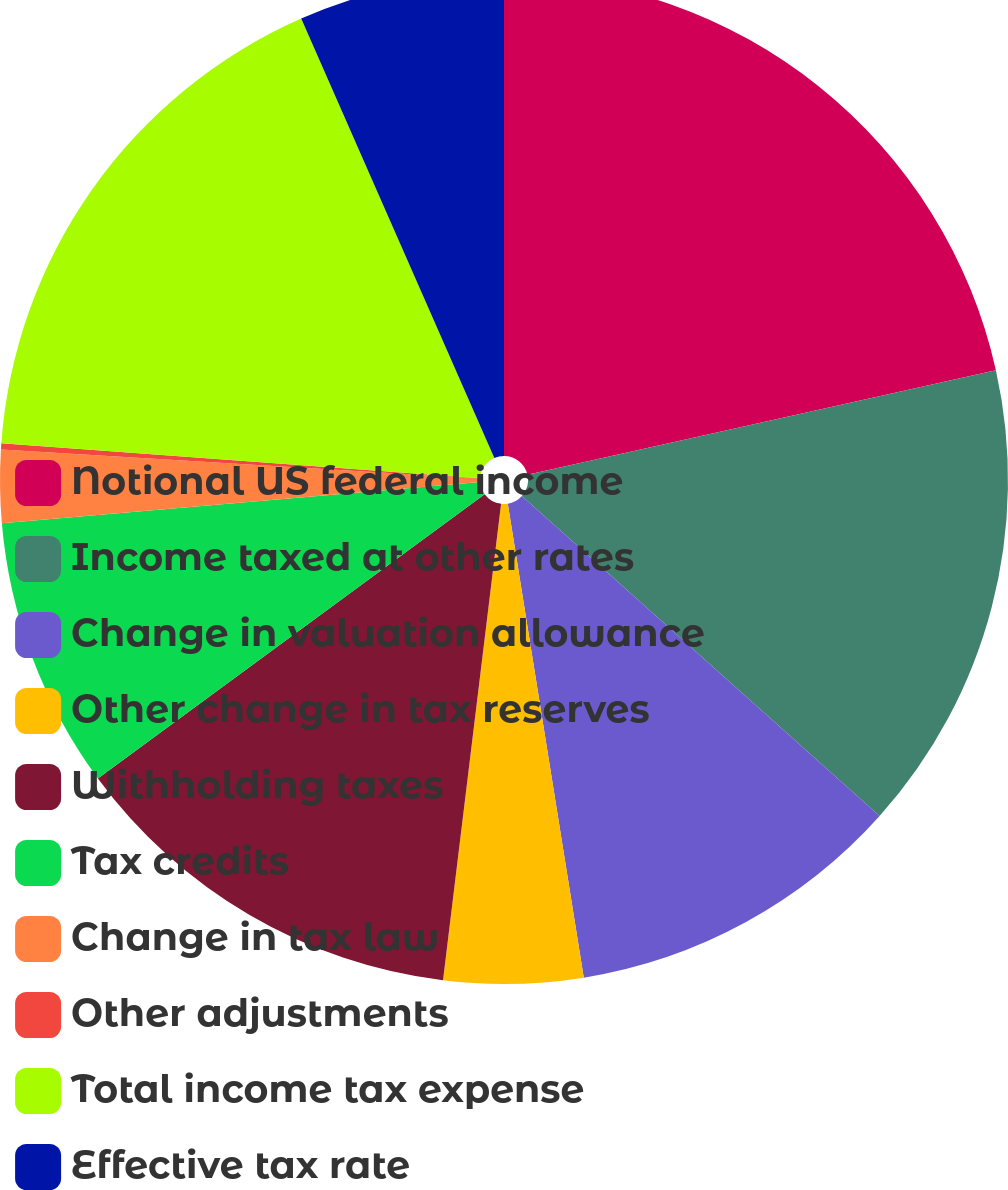Convert chart. <chart><loc_0><loc_0><loc_500><loc_500><pie_chart><fcel>Notional US federal income<fcel>Income taxed at other rates<fcel>Change in valuation allowance<fcel>Other change in tax reserves<fcel>Withholding taxes<fcel>Tax credits<fcel>Change in tax law<fcel>Other adjustments<fcel>Total income tax expense<fcel>Effective tax rate<nl><fcel>21.5%<fcel>15.11%<fcel>10.85%<fcel>4.46%<fcel>12.98%<fcel>8.72%<fcel>2.33%<fcel>0.2%<fcel>17.24%<fcel>6.59%<nl></chart> 